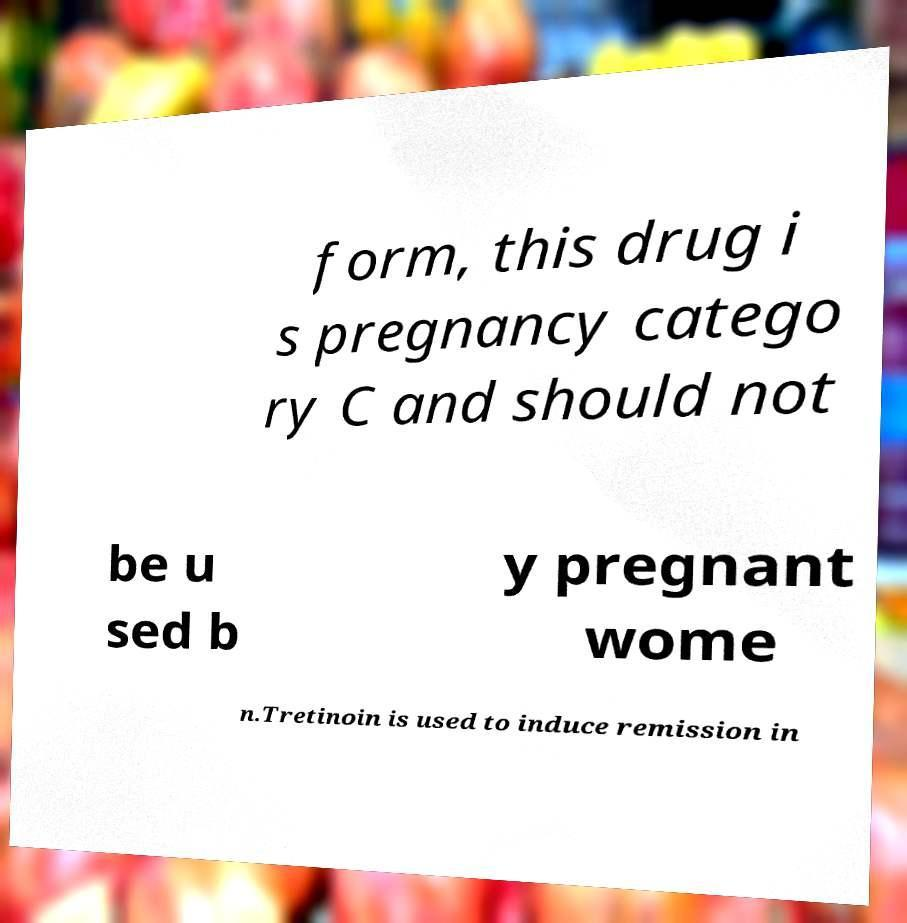Please identify and transcribe the text found in this image. form, this drug i s pregnancy catego ry C and should not be u sed b y pregnant wome n.Tretinoin is used to induce remission in 